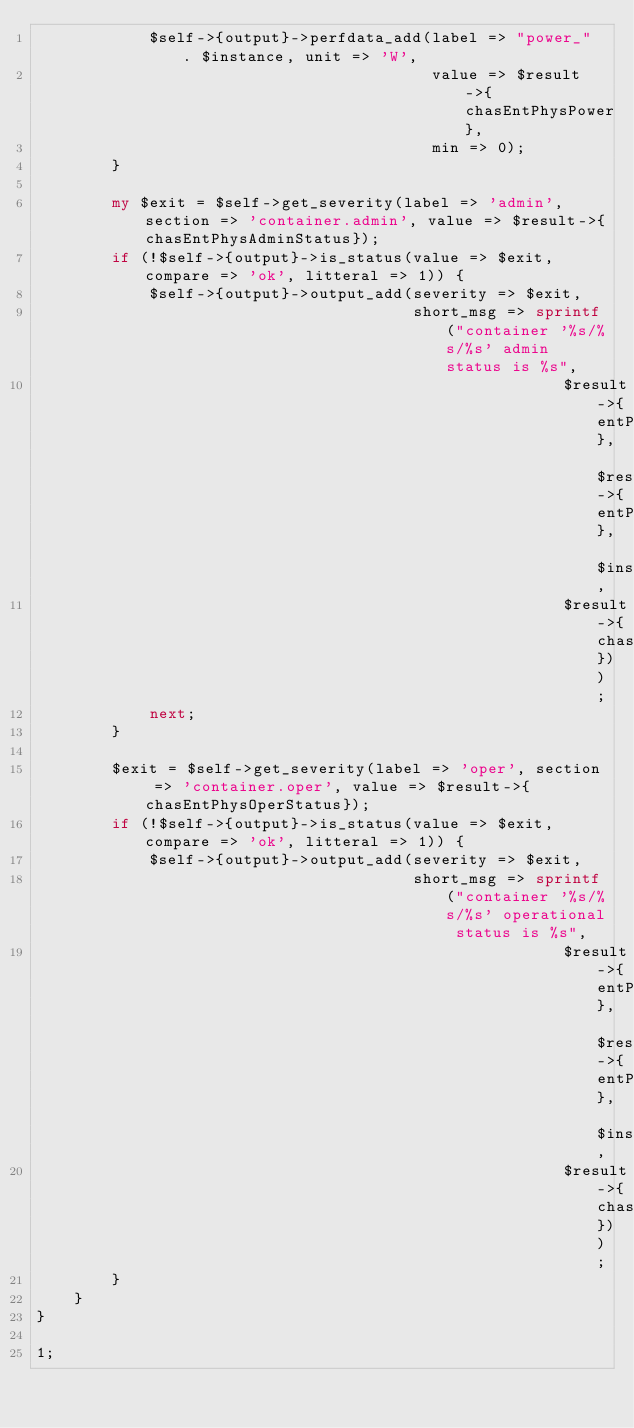Convert code to text. <code><loc_0><loc_0><loc_500><loc_500><_Perl_>            $self->{output}->perfdata_add(label => "power_" . $instance, unit => 'W',
                                          value => $result->{chasEntPhysPower},
                                          min => 0);
        }
        
        my $exit = $self->get_severity(label => 'admin', section => 'container.admin', value => $result->{chasEntPhysAdminStatus});
        if (!$self->{output}->is_status(value => $exit, compare => 'ok', litteral => 1)) {
            $self->{output}->output_add(severity => $exit,
                                        short_msg => sprintf("container '%s/%s/%s' admin status is %s",
                                                        $result->{entPhysicalName}, $result->{entPhysicalDescr}, $instance, 
                                                        $result->{chasEntPhysAdminStatus}));
            next;
        }

        $exit = $self->get_severity(label => 'oper', section => 'container.oper', value => $result->{chasEntPhysOperStatus});
        if (!$self->{output}->is_status(value => $exit, compare => 'ok', litteral => 1)) {
            $self->{output}->output_add(severity => $exit,
                                        short_msg => sprintf("container '%s/%s/%s' operational status is %s",
                                                        $result->{entPhysicalName}, $result->{entPhysicalDescr}, $instance, 
                                                        $result->{chasEntPhysOperStatus}));
        }
    }
}

1;
</code> 